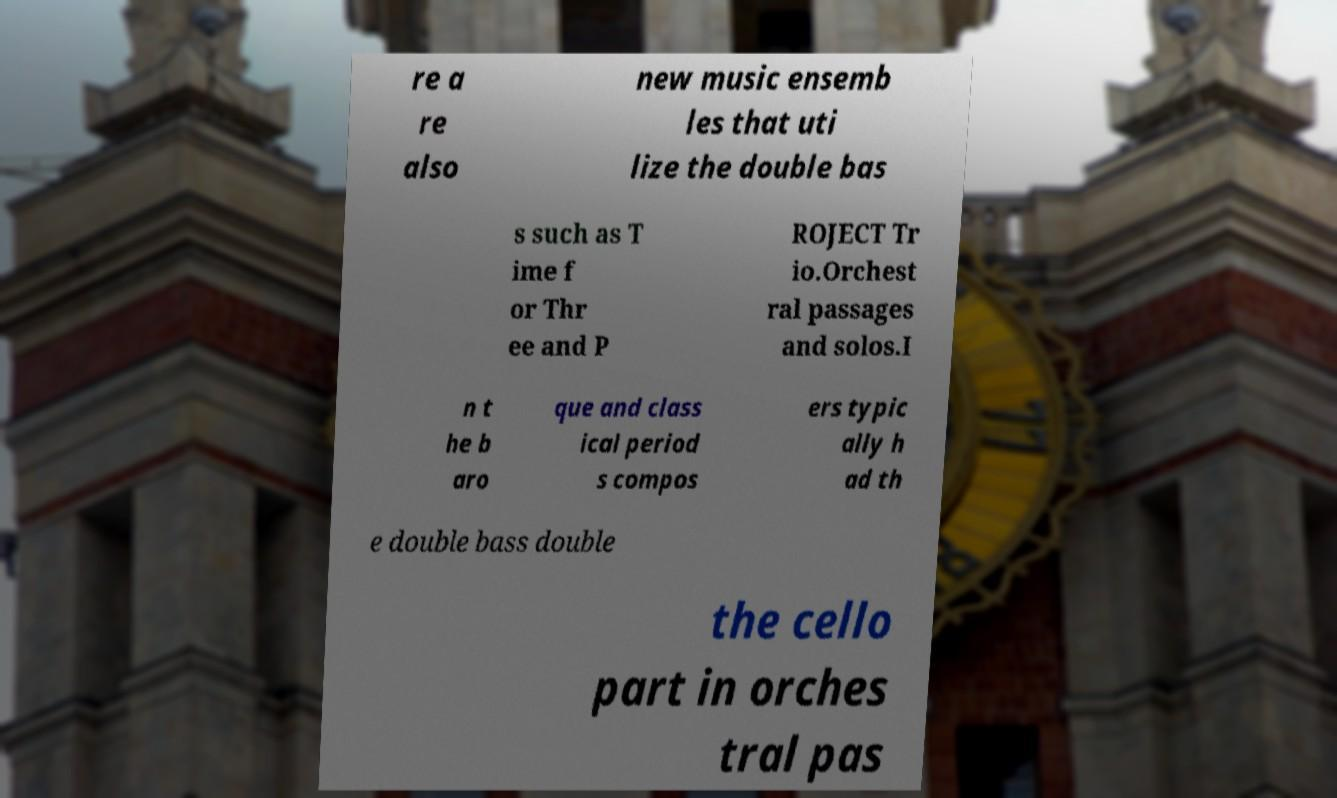For documentation purposes, I need the text within this image transcribed. Could you provide that? re a re also new music ensemb les that uti lize the double bas s such as T ime f or Thr ee and P ROJECT Tr io.Orchest ral passages and solos.I n t he b aro que and class ical period s compos ers typic ally h ad th e double bass double the cello part in orches tral pas 